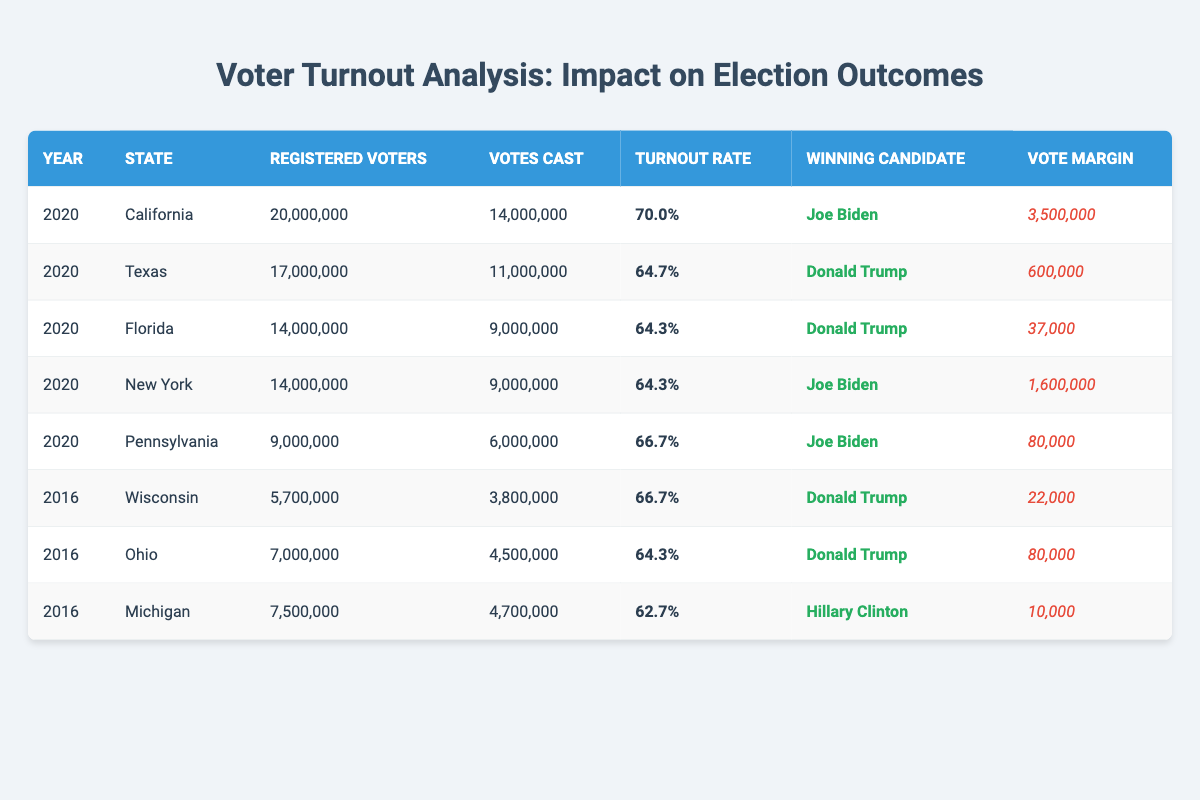What was the voter turnout rate in California in 2020? According to the table, California's voter turnout rate in 2020 is listed directly in the row corresponding to that state and year, which shows a turnout rate of 70.0%.
Answer: 70.0% Which state had the highest vote margin in the 2020 election? By comparing the vote margin values in the table for the year 2020, California has the highest vote margin listed at 3,500,000, which is greater than any other state's margin.
Answer: California In which state did Joe Biden win with the smallest vote margin in 2020? In the table, Joe Biden's smallest vote margin for the year 2020 is found by examining the rows for states where he was the winning candidate. Pennsylvania shows a vote margin of 80,000, making it the smallest compared to other states he won.
Answer: Pennsylvania What is the average turnout rate for the 2020 elections based on the table? To calculate the average turnout rate for 2020, we add the turnout rates for each state in that year (70.0 + 64.7 + 64.3 + 64.3 + 66.7) and then divide by the number of states (5). The total is 329.0, and dividing by 5 gives us an average of 65.8%.
Answer: 65.8% Was the voter turnout rate in Texas higher or lower than the national average of 66.8% for the 2020 elections? In the table, Texas's turnout rate is shown as 64.7%, which is lower than the national average of 66.8%. Therefore, the answer is based on a comparison of these two values.
Answer: Lower Which winning candidate had a higher turnout rate in the states they won: Joe Biden or Donald Trump in 2020? Joe Biden won in California (70.0%) and New York (64.3%) for an average of 67.15%. Donald Trump won in Texas (64.7%), Florida (64.3%), for an average of 64.5%. Comparing these averages shows that Biden had a higher average turnout rate in states where he won.
Answer: Joe Biden Did any state have a turnout rate below 65% in the 2016 elections? By analyzing the table for the year 2016, it appears that Michigan had a turnout rate of only 62.7%, which is below 65%, making the answer 'Yes'.
Answer: Yes What was the total number of registered voters across all states in the 2020 elections? To find the total, one must sum the registered voters from the table for each state in 2020: 20,000,000 (California) + 17,000,000 (Texas) + 14,000,000 (Florida) + 14,000,000 (New York) + 9,000,000 (Pennsylvania) = 74,000,000 registered voters.
Answer: 74,000,000 